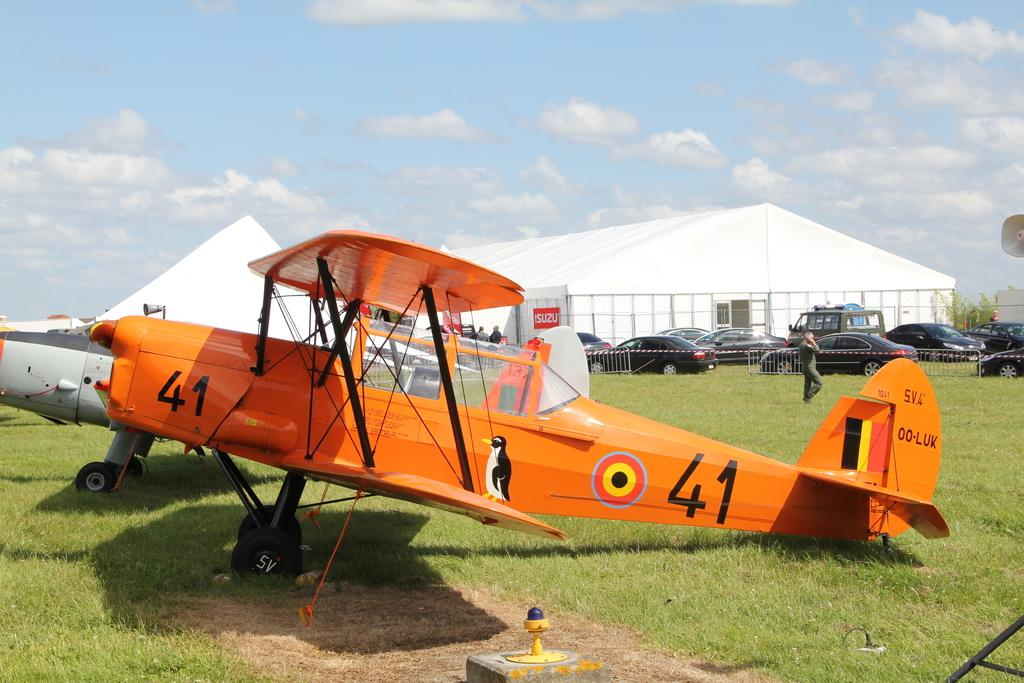<image>
Offer a succinct explanation of the picture presented. An orange plane on the ground labeled 41 